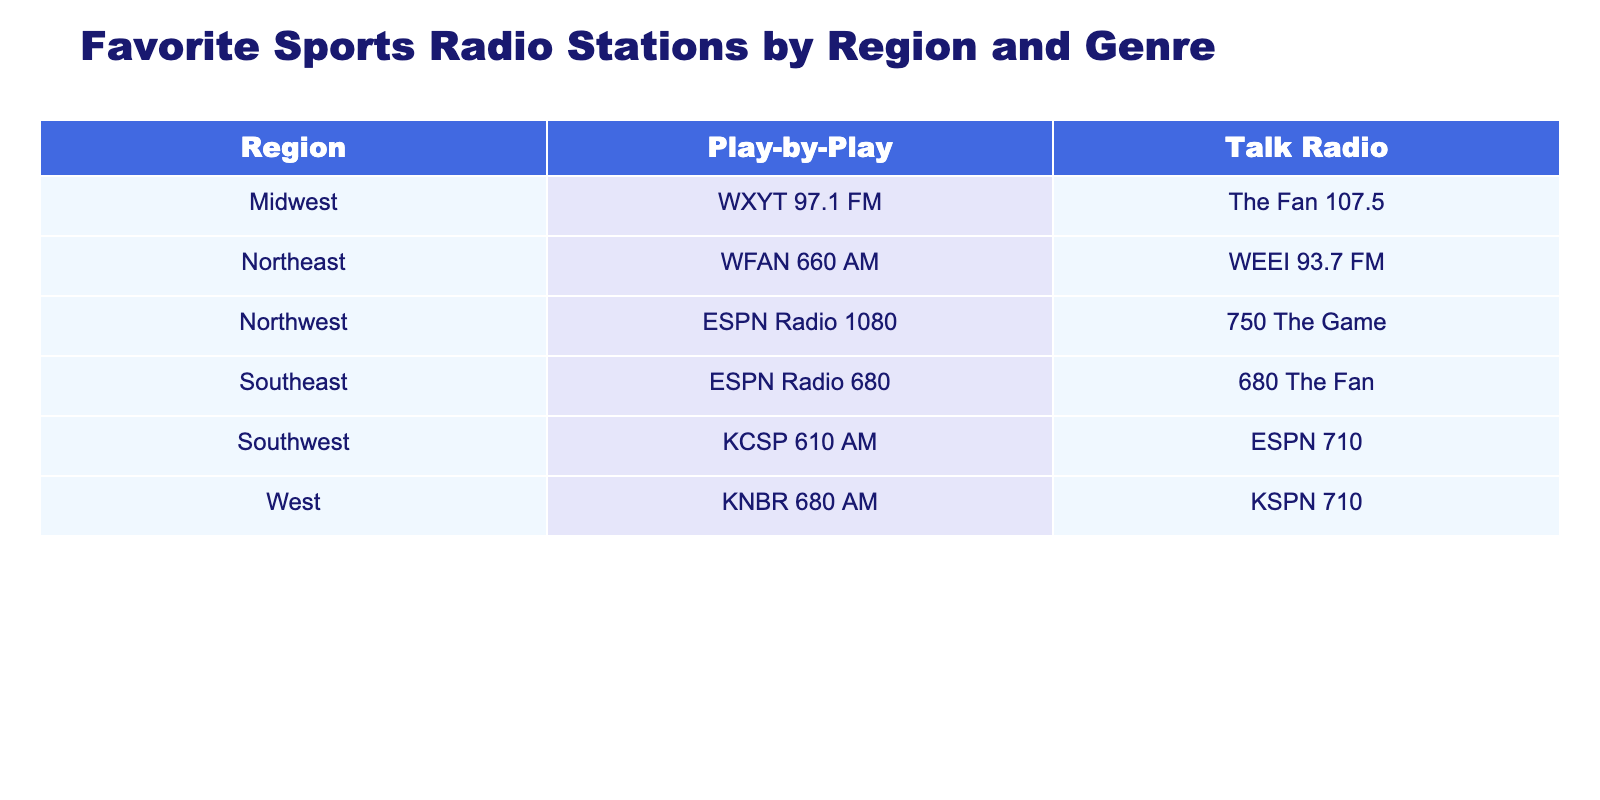What sports radio station is listed for the Midwest region under Talk Radio? The table shows the listing for the Midwest region in the Talk Radio genre, which identifies the station as The Fan 107.5.
Answer: The Fan 107.5 Which region has the ESPN radio station for Play-by-Play? In the table, ESPN Radio 680 is indicated as the Play-by-Play station under the Southeast region.
Answer: Southeast How many Talk Radio stations are available in the Northeast region? The table shows two stations under Talk Radio for the Northeast region: WEEI 93.7 FM and WFAN 660 AM.
Answer: 2 Is there a Play-by-Play station in the Northwest region? Looking at the table, ESPN Radio 1080 is listed under the Northwest region for the Play-by-Play genre, confirming its existence.
Answer: Yes Which region has the least variety in station genres? Analyzing the table, both the Midwest and the Southeast region have the same genres (one each of Talk Radio and Play-by-Play), indicating they have the least variety.
Answer: Midwest and Southeast 